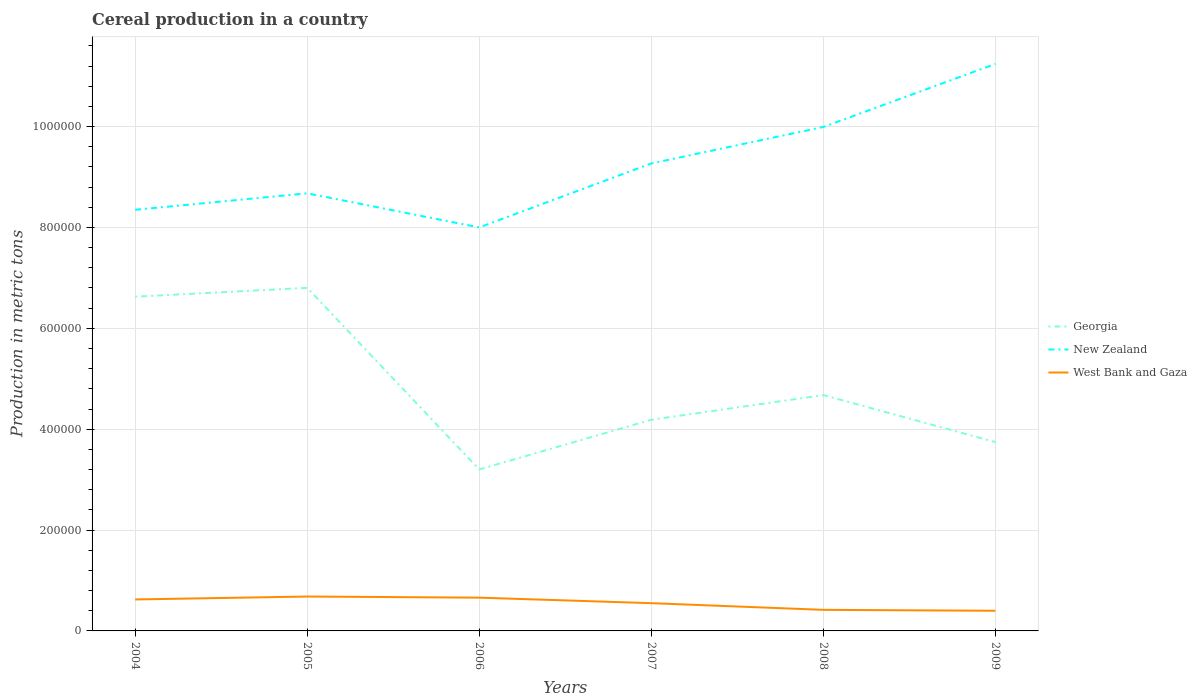Does the line corresponding to New Zealand intersect with the line corresponding to Georgia?
Your response must be concise. No. Across all years, what is the maximum total cereal production in Georgia?
Offer a terse response. 3.20e+05. What is the total total cereal production in Georgia in the graph?
Make the answer very short. 2.44e+05. What is the difference between the highest and the second highest total cereal production in New Zealand?
Your answer should be compact. 3.24e+05. How many years are there in the graph?
Your answer should be compact. 6. Where does the legend appear in the graph?
Make the answer very short. Center right. How many legend labels are there?
Your response must be concise. 3. How are the legend labels stacked?
Keep it short and to the point. Vertical. What is the title of the graph?
Keep it short and to the point. Cereal production in a country. What is the label or title of the X-axis?
Ensure brevity in your answer.  Years. What is the label or title of the Y-axis?
Your answer should be compact. Production in metric tons. What is the Production in metric tons in Georgia in 2004?
Your response must be concise. 6.63e+05. What is the Production in metric tons of New Zealand in 2004?
Your answer should be very brief. 8.35e+05. What is the Production in metric tons of West Bank and Gaza in 2004?
Give a very brief answer. 6.24e+04. What is the Production in metric tons in Georgia in 2005?
Your answer should be compact. 6.80e+05. What is the Production in metric tons in New Zealand in 2005?
Give a very brief answer. 8.68e+05. What is the Production in metric tons in West Bank and Gaza in 2005?
Provide a succinct answer. 6.82e+04. What is the Production in metric tons of Georgia in 2006?
Your answer should be very brief. 3.20e+05. What is the Production in metric tons in New Zealand in 2006?
Provide a succinct answer. 8.00e+05. What is the Production in metric tons in West Bank and Gaza in 2006?
Offer a very short reply. 6.60e+04. What is the Production in metric tons in Georgia in 2007?
Your answer should be very brief. 4.19e+05. What is the Production in metric tons in New Zealand in 2007?
Provide a short and direct response. 9.27e+05. What is the Production in metric tons in West Bank and Gaza in 2007?
Make the answer very short. 5.50e+04. What is the Production in metric tons in Georgia in 2008?
Make the answer very short. 4.68e+05. What is the Production in metric tons in New Zealand in 2008?
Your answer should be compact. 9.99e+05. What is the Production in metric tons in West Bank and Gaza in 2008?
Give a very brief answer. 4.18e+04. What is the Production in metric tons in Georgia in 2009?
Give a very brief answer. 3.74e+05. What is the Production in metric tons in New Zealand in 2009?
Give a very brief answer. 1.12e+06. What is the Production in metric tons in West Bank and Gaza in 2009?
Provide a succinct answer. 4.00e+04. Across all years, what is the maximum Production in metric tons of Georgia?
Offer a terse response. 6.80e+05. Across all years, what is the maximum Production in metric tons in New Zealand?
Give a very brief answer. 1.12e+06. Across all years, what is the maximum Production in metric tons of West Bank and Gaza?
Your response must be concise. 6.82e+04. Across all years, what is the minimum Production in metric tons in Georgia?
Your answer should be compact. 3.20e+05. Across all years, what is the minimum Production in metric tons of New Zealand?
Your answer should be compact. 8.00e+05. Across all years, what is the minimum Production in metric tons in West Bank and Gaza?
Give a very brief answer. 4.00e+04. What is the total Production in metric tons of Georgia in the graph?
Provide a short and direct response. 2.92e+06. What is the total Production in metric tons of New Zealand in the graph?
Your response must be concise. 5.55e+06. What is the total Production in metric tons in West Bank and Gaza in the graph?
Keep it short and to the point. 3.33e+05. What is the difference between the Production in metric tons of Georgia in 2004 and that in 2005?
Provide a succinct answer. -1.76e+04. What is the difference between the Production in metric tons in New Zealand in 2004 and that in 2005?
Keep it short and to the point. -3.27e+04. What is the difference between the Production in metric tons in West Bank and Gaza in 2004 and that in 2005?
Offer a terse response. -5785. What is the difference between the Production in metric tons of Georgia in 2004 and that in 2006?
Give a very brief answer. 3.43e+05. What is the difference between the Production in metric tons of New Zealand in 2004 and that in 2006?
Provide a short and direct response. 3.50e+04. What is the difference between the Production in metric tons in West Bank and Gaza in 2004 and that in 2006?
Provide a succinct answer. -3558. What is the difference between the Production in metric tons of Georgia in 2004 and that in 2007?
Provide a succinct answer. 2.44e+05. What is the difference between the Production in metric tons in New Zealand in 2004 and that in 2007?
Your response must be concise. -9.19e+04. What is the difference between the Production in metric tons of West Bank and Gaza in 2004 and that in 2007?
Provide a short and direct response. 7367. What is the difference between the Production in metric tons of Georgia in 2004 and that in 2008?
Your response must be concise. 1.95e+05. What is the difference between the Production in metric tons of New Zealand in 2004 and that in 2008?
Your answer should be very brief. -1.64e+05. What is the difference between the Production in metric tons of West Bank and Gaza in 2004 and that in 2008?
Make the answer very short. 2.06e+04. What is the difference between the Production in metric tons of Georgia in 2004 and that in 2009?
Make the answer very short. 2.88e+05. What is the difference between the Production in metric tons of New Zealand in 2004 and that in 2009?
Your answer should be compact. -2.89e+05. What is the difference between the Production in metric tons of West Bank and Gaza in 2004 and that in 2009?
Offer a very short reply. 2.24e+04. What is the difference between the Production in metric tons in Georgia in 2005 and that in 2006?
Your answer should be compact. 3.60e+05. What is the difference between the Production in metric tons in New Zealand in 2005 and that in 2006?
Provide a short and direct response. 6.77e+04. What is the difference between the Production in metric tons in West Bank and Gaza in 2005 and that in 2006?
Your answer should be compact. 2227. What is the difference between the Production in metric tons in Georgia in 2005 and that in 2007?
Give a very brief answer. 2.62e+05. What is the difference between the Production in metric tons in New Zealand in 2005 and that in 2007?
Your answer should be compact. -5.92e+04. What is the difference between the Production in metric tons in West Bank and Gaza in 2005 and that in 2007?
Ensure brevity in your answer.  1.32e+04. What is the difference between the Production in metric tons of Georgia in 2005 and that in 2008?
Make the answer very short. 2.13e+05. What is the difference between the Production in metric tons in New Zealand in 2005 and that in 2008?
Provide a succinct answer. -1.32e+05. What is the difference between the Production in metric tons in West Bank and Gaza in 2005 and that in 2008?
Your answer should be compact. 2.64e+04. What is the difference between the Production in metric tons of Georgia in 2005 and that in 2009?
Offer a terse response. 3.06e+05. What is the difference between the Production in metric tons of New Zealand in 2005 and that in 2009?
Your answer should be very brief. -2.57e+05. What is the difference between the Production in metric tons of West Bank and Gaza in 2005 and that in 2009?
Offer a very short reply. 2.82e+04. What is the difference between the Production in metric tons of Georgia in 2006 and that in 2007?
Make the answer very short. -9.86e+04. What is the difference between the Production in metric tons of New Zealand in 2006 and that in 2007?
Provide a succinct answer. -1.27e+05. What is the difference between the Production in metric tons in West Bank and Gaza in 2006 and that in 2007?
Your response must be concise. 1.09e+04. What is the difference between the Production in metric tons in Georgia in 2006 and that in 2008?
Keep it short and to the point. -1.47e+05. What is the difference between the Production in metric tons of New Zealand in 2006 and that in 2008?
Make the answer very short. -1.99e+05. What is the difference between the Production in metric tons in West Bank and Gaza in 2006 and that in 2008?
Provide a succinct answer. 2.42e+04. What is the difference between the Production in metric tons of Georgia in 2006 and that in 2009?
Provide a short and direct response. -5.43e+04. What is the difference between the Production in metric tons of New Zealand in 2006 and that in 2009?
Provide a succinct answer. -3.24e+05. What is the difference between the Production in metric tons in West Bank and Gaza in 2006 and that in 2009?
Ensure brevity in your answer.  2.60e+04. What is the difference between the Production in metric tons in Georgia in 2007 and that in 2008?
Ensure brevity in your answer.  -4.89e+04. What is the difference between the Production in metric tons of New Zealand in 2007 and that in 2008?
Offer a terse response. -7.24e+04. What is the difference between the Production in metric tons of West Bank and Gaza in 2007 and that in 2008?
Provide a succinct answer. 1.32e+04. What is the difference between the Production in metric tons in Georgia in 2007 and that in 2009?
Offer a very short reply. 4.43e+04. What is the difference between the Production in metric tons of New Zealand in 2007 and that in 2009?
Your answer should be compact. -1.97e+05. What is the difference between the Production in metric tons of West Bank and Gaza in 2007 and that in 2009?
Your response must be concise. 1.51e+04. What is the difference between the Production in metric tons of Georgia in 2008 and that in 2009?
Give a very brief answer. 9.31e+04. What is the difference between the Production in metric tons of New Zealand in 2008 and that in 2009?
Make the answer very short. -1.25e+05. What is the difference between the Production in metric tons of West Bank and Gaza in 2008 and that in 2009?
Your answer should be compact. 1830. What is the difference between the Production in metric tons in Georgia in 2004 and the Production in metric tons in New Zealand in 2005?
Ensure brevity in your answer.  -2.05e+05. What is the difference between the Production in metric tons of Georgia in 2004 and the Production in metric tons of West Bank and Gaza in 2005?
Keep it short and to the point. 5.95e+05. What is the difference between the Production in metric tons in New Zealand in 2004 and the Production in metric tons in West Bank and Gaza in 2005?
Your response must be concise. 7.67e+05. What is the difference between the Production in metric tons of Georgia in 2004 and the Production in metric tons of New Zealand in 2006?
Provide a succinct answer. -1.37e+05. What is the difference between the Production in metric tons of Georgia in 2004 and the Production in metric tons of West Bank and Gaza in 2006?
Your answer should be very brief. 5.97e+05. What is the difference between the Production in metric tons in New Zealand in 2004 and the Production in metric tons in West Bank and Gaza in 2006?
Your answer should be compact. 7.69e+05. What is the difference between the Production in metric tons of Georgia in 2004 and the Production in metric tons of New Zealand in 2007?
Ensure brevity in your answer.  -2.64e+05. What is the difference between the Production in metric tons of Georgia in 2004 and the Production in metric tons of West Bank and Gaza in 2007?
Your answer should be very brief. 6.08e+05. What is the difference between the Production in metric tons in New Zealand in 2004 and the Production in metric tons in West Bank and Gaza in 2007?
Keep it short and to the point. 7.80e+05. What is the difference between the Production in metric tons in Georgia in 2004 and the Production in metric tons in New Zealand in 2008?
Your answer should be very brief. -3.37e+05. What is the difference between the Production in metric tons in Georgia in 2004 and the Production in metric tons in West Bank and Gaza in 2008?
Offer a very short reply. 6.21e+05. What is the difference between the Production in metric tons in New Zealand in 2004 and the Production in metric tons in West Bank and Gaza in 2008?
Keep it short and to the point. 7.93e+05. What is the difference between the Production in metric tons of Georgia in 2004 and the Production in metric tons of New Zealand in 2009?
Provide a succinct answer. -4.62e+05. What is the difference between the Production in metric tons in Georgia in 2004 and the Production in metric tons in West Bank and Gaza in 2009?
Your response must be concise. 6.23e+05. What is the difference between the Production in metric tons of New Zealand in 2004 and the Production in metric tons of West Bank and Gaza in 2009?
Your answer should be very brief. 7.95e+05. What is the difference between the Production in metric tons of Georgia in 2005 and the Production in metric tons of New Zealand in 2006?
Keep it short and to the point. -1.20e+05. What is the difference between the Production in metric tons of Georgia in 2005 and the Production in metric tons of West Bank and Gaza in 2006?
Keep it short and to the point. 6.14e+05. What is the difference between the Production in metric tons of New Zealand in 2005 and the Production in metric tons of West Bank and Gaza in 2006?
Provide a short and direct response. 8.02e+05. What is the difference between the Production in metric tons of Georgia in 2005 and the Production in metric tons of New Zealand in 2007?
Give a very brief answer. -2.47e+05. What is the difference between the Production in metric tons of Georgia in 2005 and the Production in metric tons of West Bank and Gaza in 2007?
Provide a short and direct response. 6.25e+05. What is the difference between the Production in metric tons of New Zealand in 2005 and the Production in metric tons of West Bank and Gaza in 2007?
Your response must be concise. 8.13e+05. What is the difference between the Production in metric tons in Georgia in 2005 and the Production in metric tons in New Zealand in 2008?
Your answer should be compact. -3.19e+05. What is the difference between the Production in metric tons in Georgia in 2005 and the Production in metric tons in West Bank and Gaza in 2008?
Your response must be concise. 6.38e+05. What is the difference between the Production in metric tons in New Zealand in 2005 and the Production in metric tons in West Bank and Gaza in 2008?
Provide a succinct answer. 8.26e+05. What is the difference between the Production in metric tons in Georgia in 2005 and the Production in metric tons in New Zealand in 2009?
Keep it short and to the point. -4.44e+05. What is the difference between the Production in metric tons of Georgia in 2005 and the Production in metric tons of West Bank and Gaza in 2009?
Offer a very short reply. 6.40e+05. What is the difference between the Production in metric tons in New Zealand in 2005 and the Production in metric tons in West Bank and Gaza in 2009?
Offer a terse response. 8.28e+05. What is the difference between the Production in metric tons of Georgia in 2006 and the Production in metric tons of New Zealand in 2007?
Give a very brief answer. -6.07e+05. What is the difference between the Production in metric tons of Georgia in 2006 and the Production in metric tons of West Bank and Gaza in 2007?
Offer a terse response. 2.65e+05. What is the difference between the Production in metric tons of New Zealand in 2006 and the Production in metric tons of West Bank and Gaza in 2007?
Your response must be concise. 7.45e+05. What is the difference between the Production in metric tons of Georgia in 2006 and the Production in metric tons of New Zealand in 2008?
Make the answer very short. -6.79e+05. What is the difference between the Production in metric tons in Georgia in 2006 and the Production in metric tons in West Bank and Gaza in 2008?
Make the answer very short. 2.78e+05. What is the difference between the Production in metric tons in New Zealand in 2006 and the Production in metric tons in West Bank and Gaza in 2008?
Ensure brevity in your answer.  7.58e+05. What is the difference between the Production in metric tons of Georgia in 2006 and the Production in metric tons of New Zealand in 2009?
Provide a succinct answer. -8.04e+05. What is the difference between the Production in metric tons of Georgia in 2006 and the Production in metric tons of West Bank and Gaza in 2009?
Offer a very short reply. 2.80e+05. What is the difference between the Production in metric tons of New Zealand in 2006 and the Production in metric tons of West Bank and Gaza in 2009?
Your answer should be compact. 7.60e+05. What is the difference between the Production in metric tons of Georgia in 2007 and the Production in metric tons of New Zealand in 2008?
Your response must be concise. -5.81e+05. What is the difference between the Production in metric tons in Georgia in 2007 and the Production in metric tons in West Bank and Gaza in 2008?
Provide a short and direct response. 3.77e+05. What is the difference between the Production in metric tons of New Zealand in 2007 and the Production in metric tons of West Bank and Gaza in 2008?
Keep it short and to the point. 8.85e+05. What is the difference between the Production in metric tons of Georgia in 2007 and the Production in metric tons of New Zealand in 2009?
Ensure brevity in your answer.  -7.06e+05. What is the difference between the Production in metric tons of Georgia in 2007 and the Production in metric tons of West Bank and Gaza in 2009?
Give a very brief answer. 3.79e+05. What is the difference between the Production in metric tons of New Zealand in 2007 and the Production in metric tons of West Bank and Gaza in 2009?
Your response must be concise. 8.87e+05. What is the difference between the Production in metric tons of Georgia in 2008 and the Production in metric tons of New Zealand in 2009?
Offer a very short reply. -6.57e+05. What is the difference between the Production in metric tons of Georgia in 2008 and the Production in metric tons of West Bank and Gaza in 2009?
Your answer should be compact. 4.28e+05. What is the difference between the Production in metric tons in New Zealand in 2008 and the Production in metric tons in West Bank and Gaza in 2009?
Give a very brief answer. 9.59e+05. What is the average Production in metric tons in Georgia per year?
Give a very brief answer. 4.87e+05. What is the average Production in metric tons of New Zealand per year?
Give a very brief answer. 9.26e+05. What is the average Production in metric tons in West Bank and Gaza per year?
Keep it short and to the point. 5.56e+04. In the year 2004, what is the difference between the Production in metric tons in Georgia and Production in metric tons in New Zealand?
Your answer should be very brief. -1.72e+05. In the year 2004, what is the difference between the Production in metric tons in Georgia and Production in metric tons in West Bank and Gaza?
Provide a succinct answer. 6.00e+05. In the year 2004, what is the difference between the Production in metric tons in New Zealand and Production in metric tons in West Bank and Gaza?
Make the answer very short. 7.73e+05. In the year 2005, what is the difference between the Production in metric tons of Georgia and Production in metric tons of New Zealand?
Ensure brevity in your answer.  -1.87e+05. In the year 2005, what is the difference between the Production in metric tons in Georgia and Production in metric tons in West Bank and Gaza?
Offer a terse response. 6.12e+05. In the year 2005, what is the difference between the Production in metric tons of New Zealand and Production in metric tons of West Bank and Gaza?
Provide a succinct answer. 8.00e+05. In the year 2006, what is the difference between the Production in metric tons in Georgia and Production in metric tons in New Zealand?
Your answer should be very brief. -4.80e+05. In the year 2006, what is the difference between the Production in metric tons in Georgia and Production in metric tons in West Bank and Gaza?
Offer a terse response. 2.54e+05. In the year 2006, what is the difference between the Production in metric tons in New Zealand and Production in metric tons in West Bank and Gaza?
Your answer should be very brief. 7.34e+05. In the year 2007, what is the difference between the Production in metric tons in Georgia and Production in metric tons in New Zealand?
Provide a succinct answer. -5.08e+05. In the year 2007, what is the difference between the Production in metric tons of Georgia and Production in metric tons of West Bank and Gaza?
Your answer should be compact. 3.64e+05. In the year 2007, what is the difference between the Production in metric tons of New Zealand and Production in metric tons of West Bank and Gaza?
Your answer should be very brief. 8.72e+05. In the year 2008, what is the difference between the Production in metric tons of Georgia and Production in metric tons of New Zealand?
Your answer should be compact. -5.32e+05. In the year 2008, what is the difference between the Production in metric tons of Georgia and Production in metric tons of West Bank and Gaza?
Your answer should be very brief. 4.26e+05. In the year 2008, what is the difference between the Production in metric tons in New Zealand and Production in metric tons in West Bank and Gaza?
Your answer should be very brief. 9.57e+05. In the year 2009, what is the difference between the Production in metric tons in Georgia and Production in metric tons in New Zealand?
Give a very brief answer. -7.50e+05. In the year 2009, what is the difference between the Production in metric tons in Georgia and Production in metric tons in West Bank and Gaza?
Give a very brief answer. 3.35e+05. In the year 2009, what is the difference between the Production in metric tons of New Zealand and Production in metric tons of West Bank and Gaza?
Your answer should be compact. 1.08e+06. What is the ratio of the Production in metric tons in Georgia in 2004 to that in 2005?
Offer a terse response. 0.97. What is the ratio of the Production in metric tons in New Zealand in 2004 to that in 2005?
Keep it short and to the point. 0.96. What is the ratio of the Production in metric tons in West Bank and Gaza in 2004 to that in 2005?
Keep it short and to the point. 0.92. What is the ratio of the Production in metric tons in Georgia in 2004 to that in 2006?
Give a very brief answer. 2.07. What is the ratio of the Production in metric tons in New Zealand in 2004 to that in 2006?
Your response must be concise. 1.04. What is the ratio of the Production in metric tons in West Bank and Gaza in 2004 to that in 2006?
Provide a short and direct response. 0.95. What is the ratio of the Production in metric tons in Georgia in 2004 to that in 2007?
Keep it short and to the point. 1.58. What is the ratio of the Production in metric tons in New Zealand in 2004 to that in 2007?
Offer a terse response. 0.9. What is the ratio of the Production in metric tons in West Bank and Gaza in 2004 to that in 2007?
Give a very brief answer. 1.13. What is the ratio of the Production in metric tons of Georgia in 2004 to that in 2008?
Your answer should be compact. 1.42. What is the ratio of the Production in metric tons in New Zealand in 2004 to that in 2008?
Your answer should be very brief. 0.84. What is the ratio of the Production in metric tons in West Bank and Gaza in 2004 to that in 2008?
Offer a very short reply. 1.49. What is the ratio of the Production in metric tons of Georgia in 2004 to that in 2009?
Provide a succinct answer. 1.77. What is the ratio of the Production in metric tons of New Zealand in 2004 to that in 2009?
Your response must be concise. 0.74. What is the ratio of the Production in metric tons of West Bank and Gaza in 2004 to that in 2009?
Provide a short and direct response. 1.56. What is the ratio of the Production in metric tons in Georgia in 2005 to that in 2006?
Give a very brief answer. 2.12. What is the ratio of the Production in metric tons of New Zealand in 2005 to that in 2006?
Keep it short and to the point. 1.08. What is the ratio of the Production in metric tons of West Bank and Gaza in 2005 to that in 2006?
Ensure brevity in your answer.  1.03. What is the ratio of the Production in metric tons of Georgia in 2005 to that in 2007?
Your answer should be compact. 1.62. What is the ratio of the Production in metric tons of New Zealand in 2005 to that in 2007?
Your answer should be very brief. 0.94. What is the ratio of the Production in metric tons of West Bank and Gaza in 2005 to that in 2007?
Your answer should be compact. 1.24. What is the ratio of the Production in metric tons of Georgia in 2005 to that in 2008?
Keep it short and to the point. 1.45. What is the ratio of the Production in metric tons in New Zealand in 2005 to that in 2008?
Provide a short and direct response. 0.87. What is the ratio of the Production in metric tons in West Bank and Gaza in 2005 to that in 2008?
Keep it short and to the point. 1.63. What is the ratio of the Production in metric tons of Georgia in 2005 to that in 2009?
Offer a very short reply. 1.82. What is the ratio of the Production in metric tons of New Zealand in 2005 to that in 2009?
Provide a short and direct response. 0.77. What is the ratio of the Production in metric tons in West Bank and Gaza in 2005 to that in 2009?
Offer a terse response. 1.71. What is the ratio of the Production in metric tons of Georgia in 2006 to that in 2007?
Offer a terse response. 0.76. What is the ratio of the Production in metric tons of New Zealand in 2006 to that in 2007?
Your answer should be compact. 0.86. What is the ratio of the Production in metric tons in West Bank and Gaza in 2006 to that in 2007?
Keep it short and to the point. 1.2. What is the ratio of the Production in metric tons in Georgia in 2006 to that in 2008?
Make the answer very short. 0.68. What is the ratio of the Production in metric tons in New Zealand in 2006 to that in 2008?
Your answer should be very brief. 0.8. What is the ratio of the Production in metric tons of West Bank and Gaza in 2006 to that in 2008?
Offer a very short reply. 1.58. What is the ratio of the Production in metric tons in Georgia in 2006 to that in 2009?
Provide a succinct answer. 0.85. What is the ratio of the Production in metric tons in New Zealand in 2006 to that in 2009?
Provide a short and direct response. 0.71. What is the ratio of the Production in metric tons of West Bank and Gaza in 2006 to that in 2009?
Keep it short and to the point. 1.65. What is the ratio of the Production in metric tons in Georgia in 2007 to that in 2008?
Provide a succinct answer. 0.9. What is the ratio of the Production in metric tons in New Zealand in 2007 to that in 2008?
Give a very brief answer. 0.93. What is the ratio of the Production in metric tons in West Bank and Gaza in 2007 to that in 2008?
Your answer should be very brief. 1.32. What is the ratio of the Production in metric tons of Georgia in 2007 to that in 2009?
Provide a short and direct response. 1.12. What is the ratio of the Production in metric tons in New Zealand in 2007 to that in 2009?
Your answer should be very brief. 0.82. What is the ratio of the Production in metric tons of West Bank and Gaza in 2007 to that in 2009?
Provide a short and direct response. 1.38. What is the ratio of the Production in metric tons of Georgia in 2008 to that in 2009?
Give a very brief answer. 1.25. What is the ratio of the Production in metric tons of New Zealand in 2008 to that in 2009?
Keep it short and to the point. 0.89. What is the ratio of the Production in metric tons in West Bank and Gaza in 2008 to that in 2009?
Your answer should be compact. 1.05. What is the difference between the highest and the second highest Production in metric tons in Georgia?
Give a very brief answer. 1.76e+04. What is the difference between the highest and the second highest Production in metric tons of New Zealand?
Provide a short and direct response. 1.25e+05. What is the difference between the highest and the second highest Production in metric tons in West Bank and Gaza?
Make the answer very short. 2227. What is the difference between the highest and the lowest Production in metric tons in Georgia?
Your response must be concise. 3.60e+05. What is the difference between the highest and the lowest Production in metric tons of New Zealand?
Your response must be concise. 3.24e+05. What is the difference between the highest and the lowest Production in metric tons in West Bank and Gaza?
Your response must be concise. 2.82e+04. 